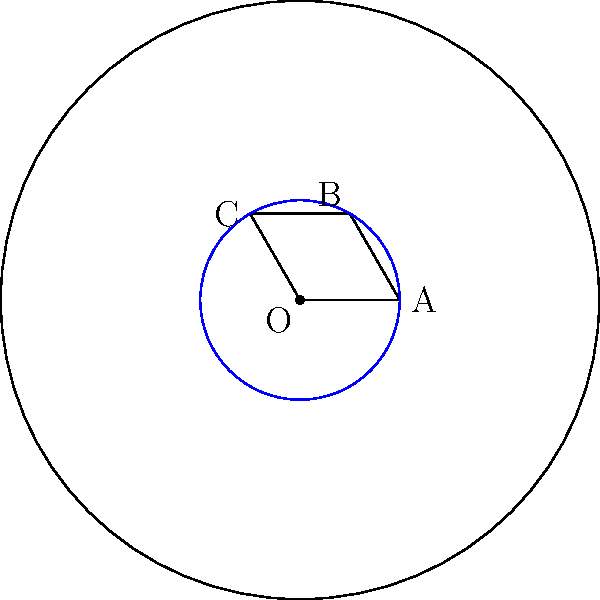In a negatively curved space (hyperbolic geometry), consider a circle with radius $r$ on a surface with constant negative curvature $K = -\frac{1}{R^2}$. How does the area $A$ of this circle compare to the area of a circle with the same radius in Euclidean geometry? Express your answer in terms of $r$ and $R$. To solve this problem, we'll follow these steps:

1) In Euclidean geometry, the area of a circle with radius $r$ is given by:
   $$A_{Euclidean} = \pi r^2$$

2) In hyperbolic geometry, the area of a circle with radius $r$ on a surface with constant negative curvature $K = -\frac{1}{R^2}$ is given by:
   $$A_{Hyperbolic} = 4\pi R^2 \sinh^2(\frac{r}{2R})$$
   where $\sinh$ is the hyperbolic sine function.

3) To compare these areas, we can calculate their ratio:
   $$\frac{A_{Hyperbolic}}{A_{Euclidean}} = \frac{4\pi R^2 \sinh^2(\frac{r}{2R})}{\pi r^2}$$

4) Simplify:
   $$\frac{A_{Hyperbolic}}{A_{Euclidean}} = 4(\frac{R}{r})^2 \sinh^2(\frac{r}{2R})$$

5) For small values of $r$ compared to $R$, we can use the Taylor expansion of $\sinh(x)$:
   $$\sinh(x) \approx x + \frac{x^3}{6} + \frac{x^5}{120} + ...$$

6) Applying this to our ratio:
   $$\frac{A_{Hyperbolic}}{A_{Euclidean}} \approx 4(\frac{R}{r})^2 [(\frac{r}{2R})^2 + \frac{1}{6}(\frac{r}{2R})^6 + ...]$$

7) Simplify:
   $$\frac{A_{Hyperbolic}}{A_{Euclidean}} \approx 1 + \frac{r^2}{12R^2} + ...$$

This shows that the area of the circle in hyperbolic geometry is always larger than in Euclidean geometry, and the difference increases as $r$ increases or as $R$ decreases (i.e., as the curvature becomes more negative).
Answer: $A_{Hyperbolic} \approx A_{Euclidean}(1 + \frac{r^2}{12R^2})$ 